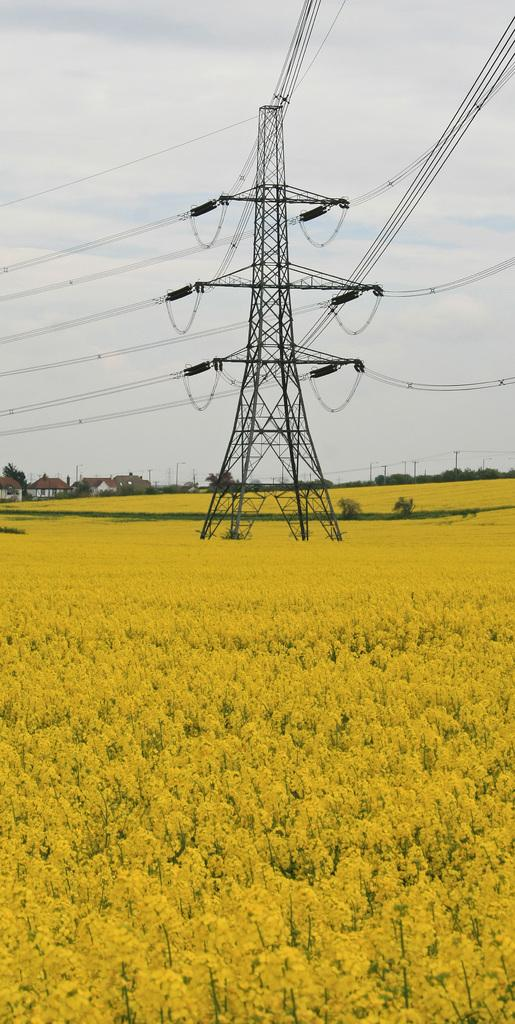What is the main structure in the image? There is a transmission pole in the image. How many wires are connected to the pole? There are many wires connected to the pole. What type of vegetation is present at the bottom of the image? There are plants in yellow color at the bottom of the image. What can be seen in the sky at the top of the image? There are clouds in the sky at the top of the image. What scent can be detected from the plants in the image? There is no information about the scent of the plants in the image, as only their color (yellow) is mentioned. 